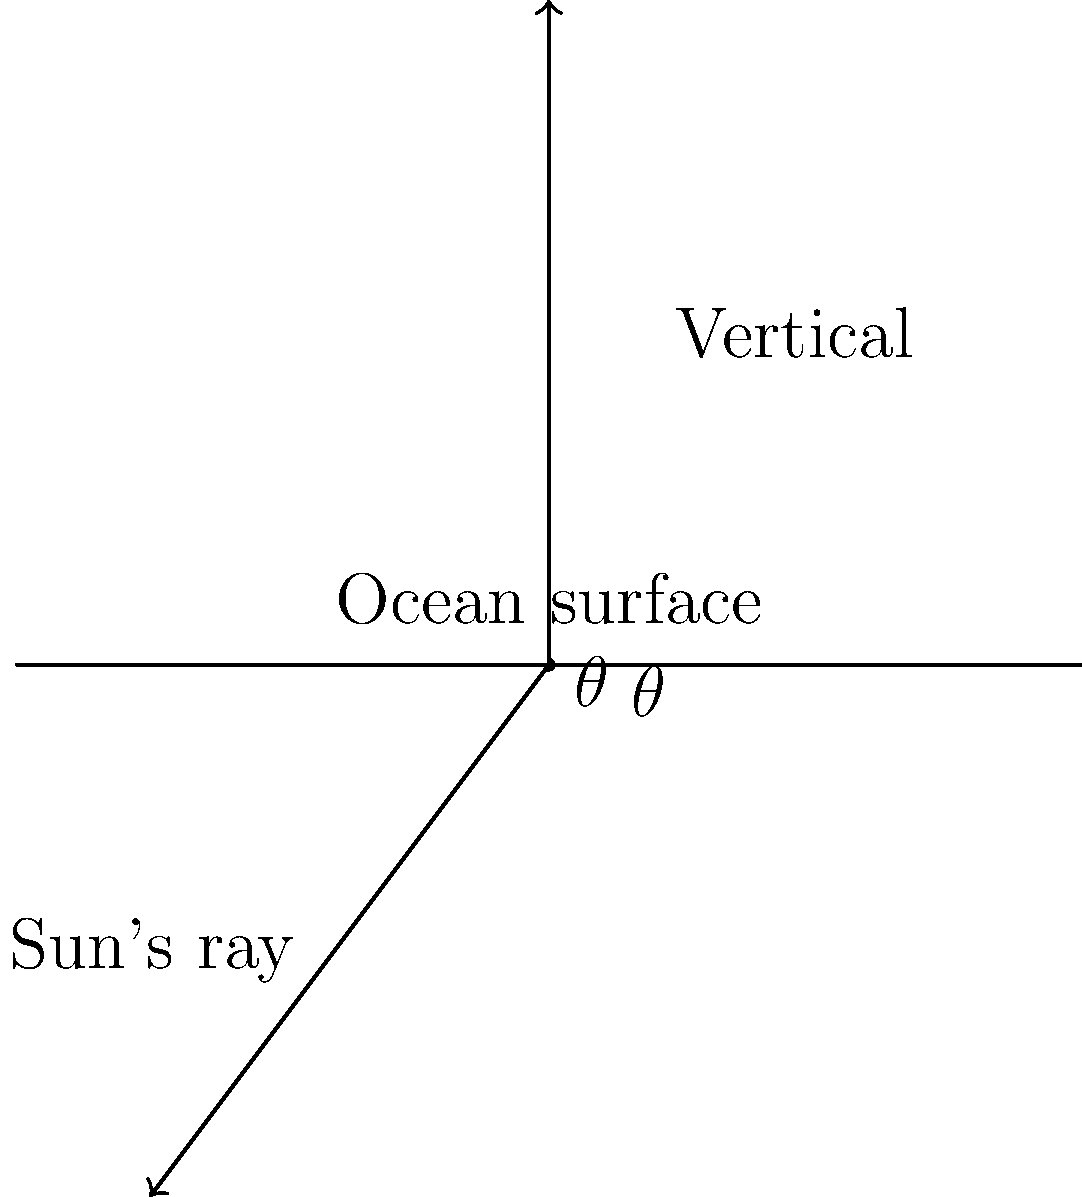As you prepare for a dive at one of your favorite spots, you notice the angle between the sun's rays and the ocean surface. If this angle is 37°, what is the angle $\theta$ between the sun's rays and the vertical, as shown in the diagram? To solve this problem, let's follow these steps:

1) First, recall that when a straight line (in this case, the vertical line) intersects two other lines (the sun's ray and the ocean surface), it forms supplementary angles.

2) Supplementary angles are two angles that add up to 180°.

3) In this case, we have:
   - The angle between the sun's rays and the ocean surface (given as 37°)
   - The angle $\theta$ we're looking for
   - These two angles are supplementary

4) We can express this relationship mathematically:
   $$ 37° + \theta = 180° $$

5) To find $\theta$, we subtract 37° from both sides:
   $$ \theta = 180° - 37° $$

6) Perform the subtraction:
   $$ \theta = 143° $$

Thus, the angle $\theta$ between the sun's rays and the vertical is 143°.
Answer: 143° 